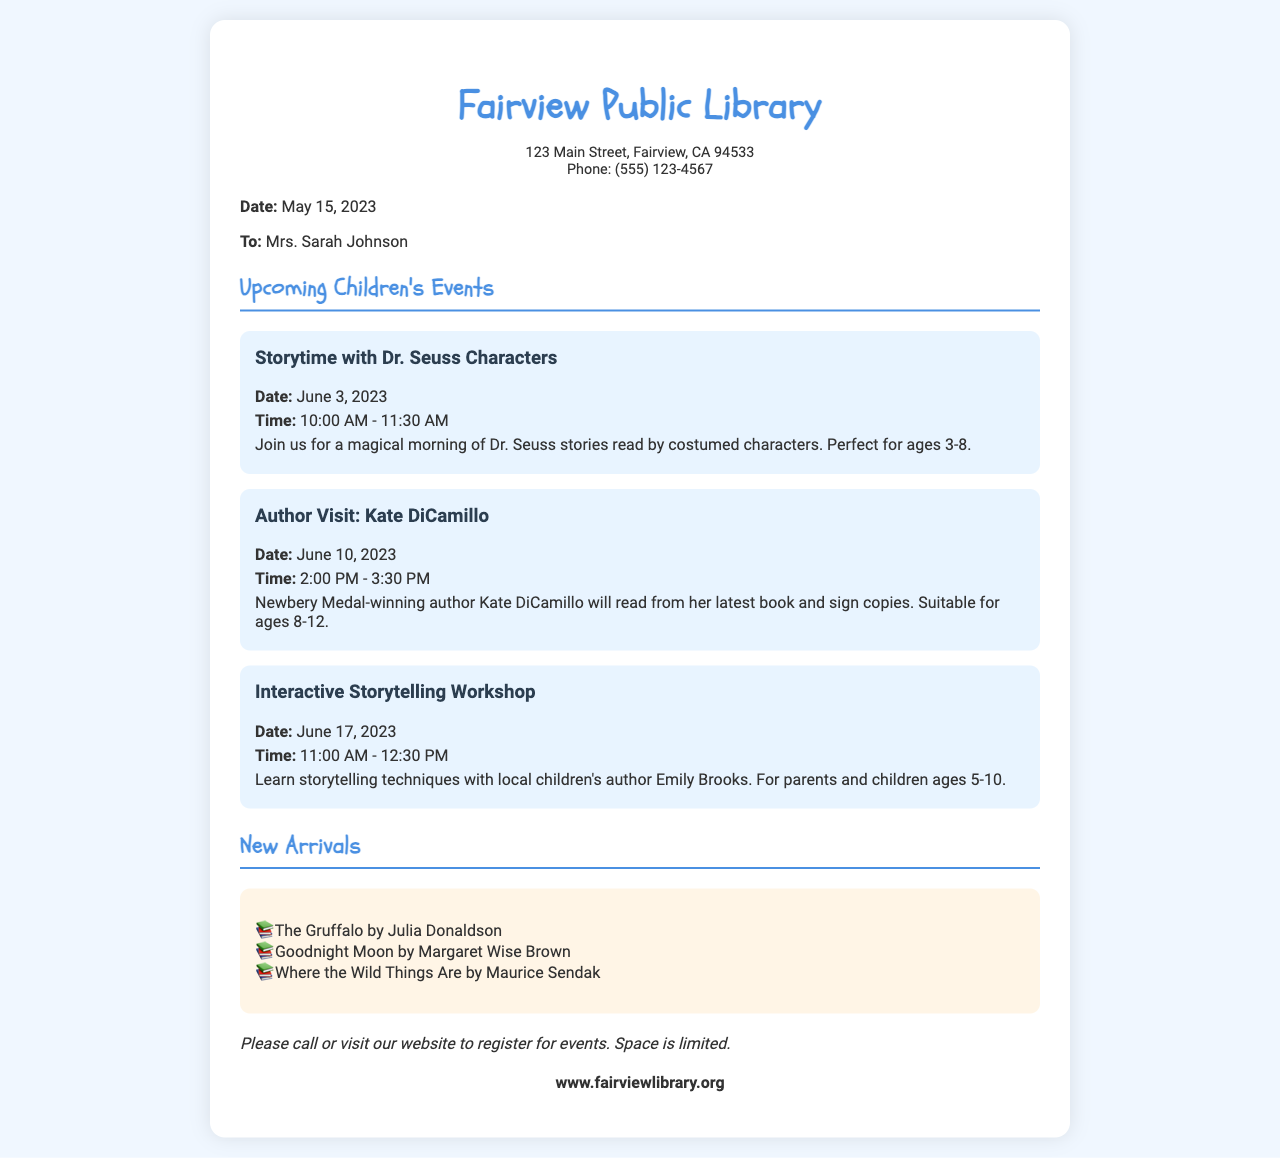What is the date for Storytime with Dr. Seuss Characters? The date for Storytime with Dr. Seuss Characters is mentioned in the document as June 3, 2023.
Answer: June 3, 2023 Who is the author visiting on June 10, 2023? The document states that the author visiting on June 10, 2023 is Kate DiCamillo.
Answer: Kate DiCamillo What age group is suitable for the Interactive Storytelling Workshop? The age group suitable for the Interactive Storytelling Workshop is mentioned as ages 5-10.
Answer: Ages 5-10 How long is the Author Visit event scheduled to last? The Author Visit event is scheduled from 2:00 PM to 3:30 PM, lasting for 1.5 hours.
Answer: 1.5 hours How many new arrivals are listed in the document? The new arrivals section lists three books in total.
Answer: Three books What is the library's website for registration? The website provided in the document for registration is mentioned as www.fairviewlibrary.org.
Answer: www.fairviewlibrary.org What is the time for the Interactive Storytelling Workshop? The time for the Interactive Storytelling Workshop is listed as 11:00 AM - 12:30 PM.
Answer: 11:00 AM - 12:30 PM What type of event is scheduled for June 3, 2023? June 3, 2023, is scheduled for Storytime with Dr. Seuss Characters as stated in the document.
Answer: Storytime with Dr. Seuss Characters 